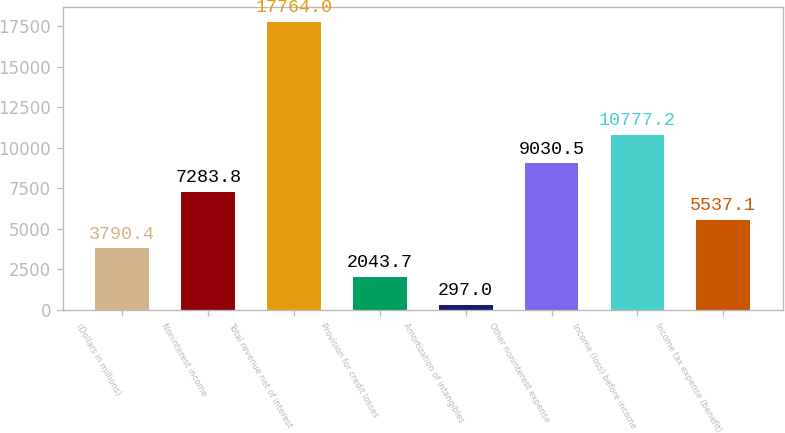<chart> <loc_0><loc_0><loc_500><loc_500><bar_chart><fcel>(Dollars in millions)<fcel>Noninterest income<fcel>Total revenue net of interest<fcel>Provision for credit losses<fcel>Amortization of intangibles<fcel>Other noninterest expense<fcel>Income (loss) before income<fcel>Income tax expense (benefit)<nl><fcel>3790.4<fcel>7283.8<fcel>17764<fcel>2043.7<fcel>297<fcel>9030.5<fcel>10777.2<fcel>5537.1<nl></chart> 